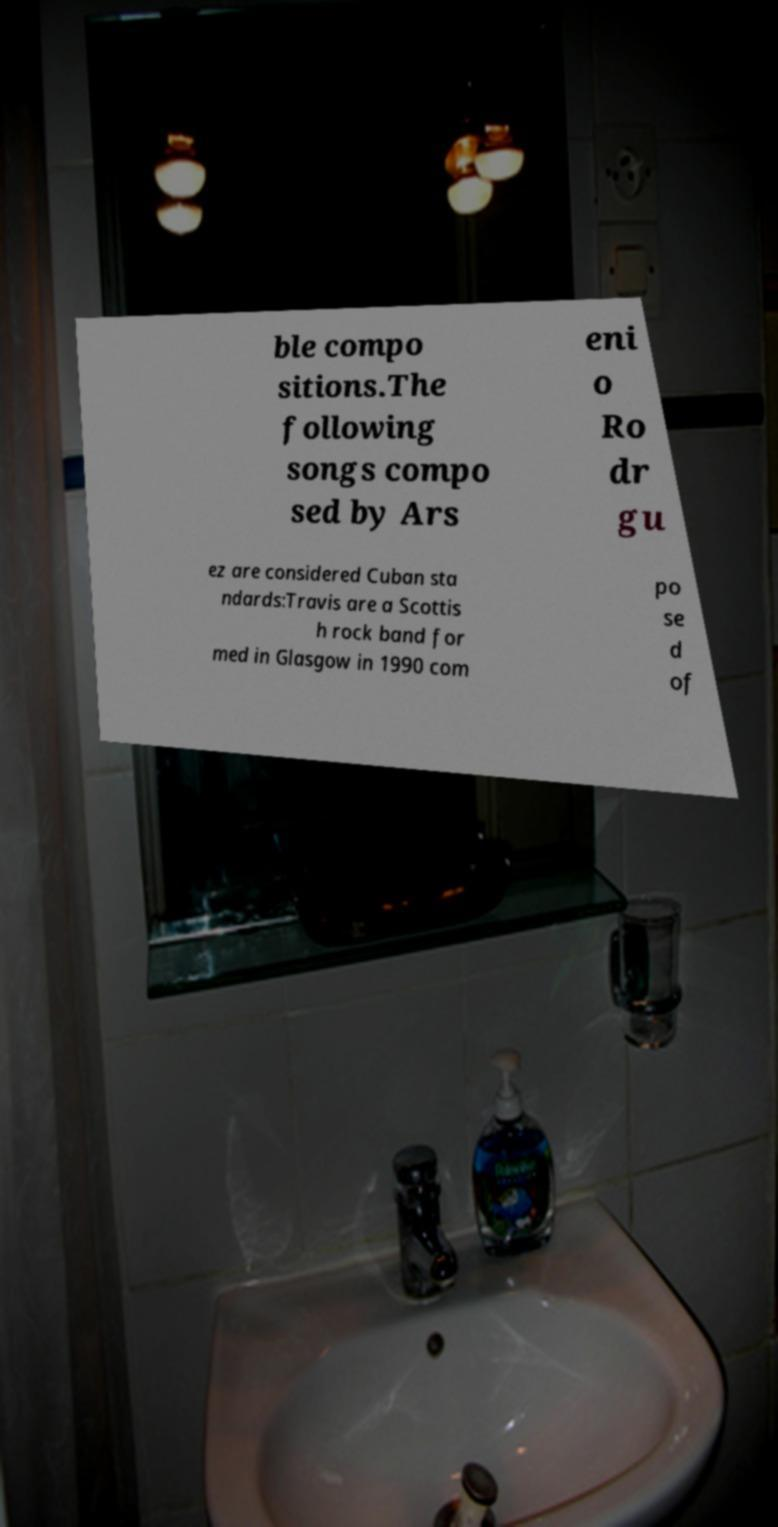Please identify and transcribe the text found in this image. ble compo sitions.The following songs compo sed by Ars eni o Ro dr gu ez are considered Cuban sta ndards:Travis are a Scottis h rock band for med in Glasgow in 1990 com po se d of 